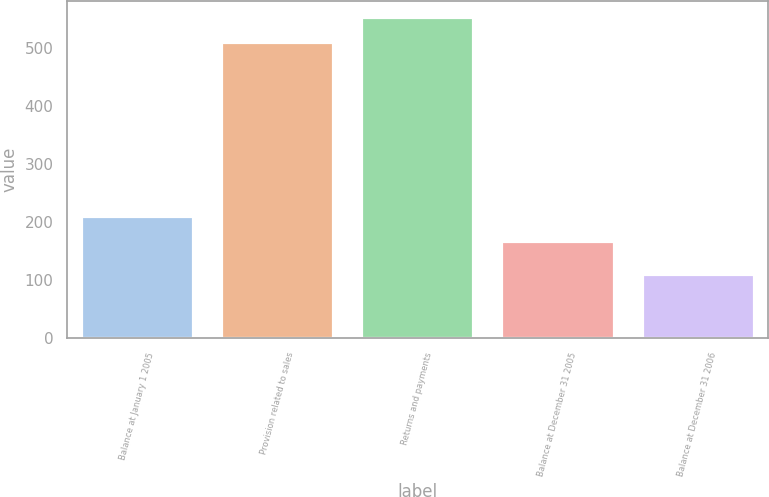Convert chart to OTSL. <chart><loc_0><loc_0><loc_500><loc_500><bar_chart><fcel>Balance at January 1 2005<fcel>Provision related to sales<fcel>Returns and payments<fcel>Balance at December 31 2005<fcel>Balance at December 31 2006<nl><fcel>210.1<fcel>509<fcel>552.1<fcel>167<fcel>111<nl></chart> 